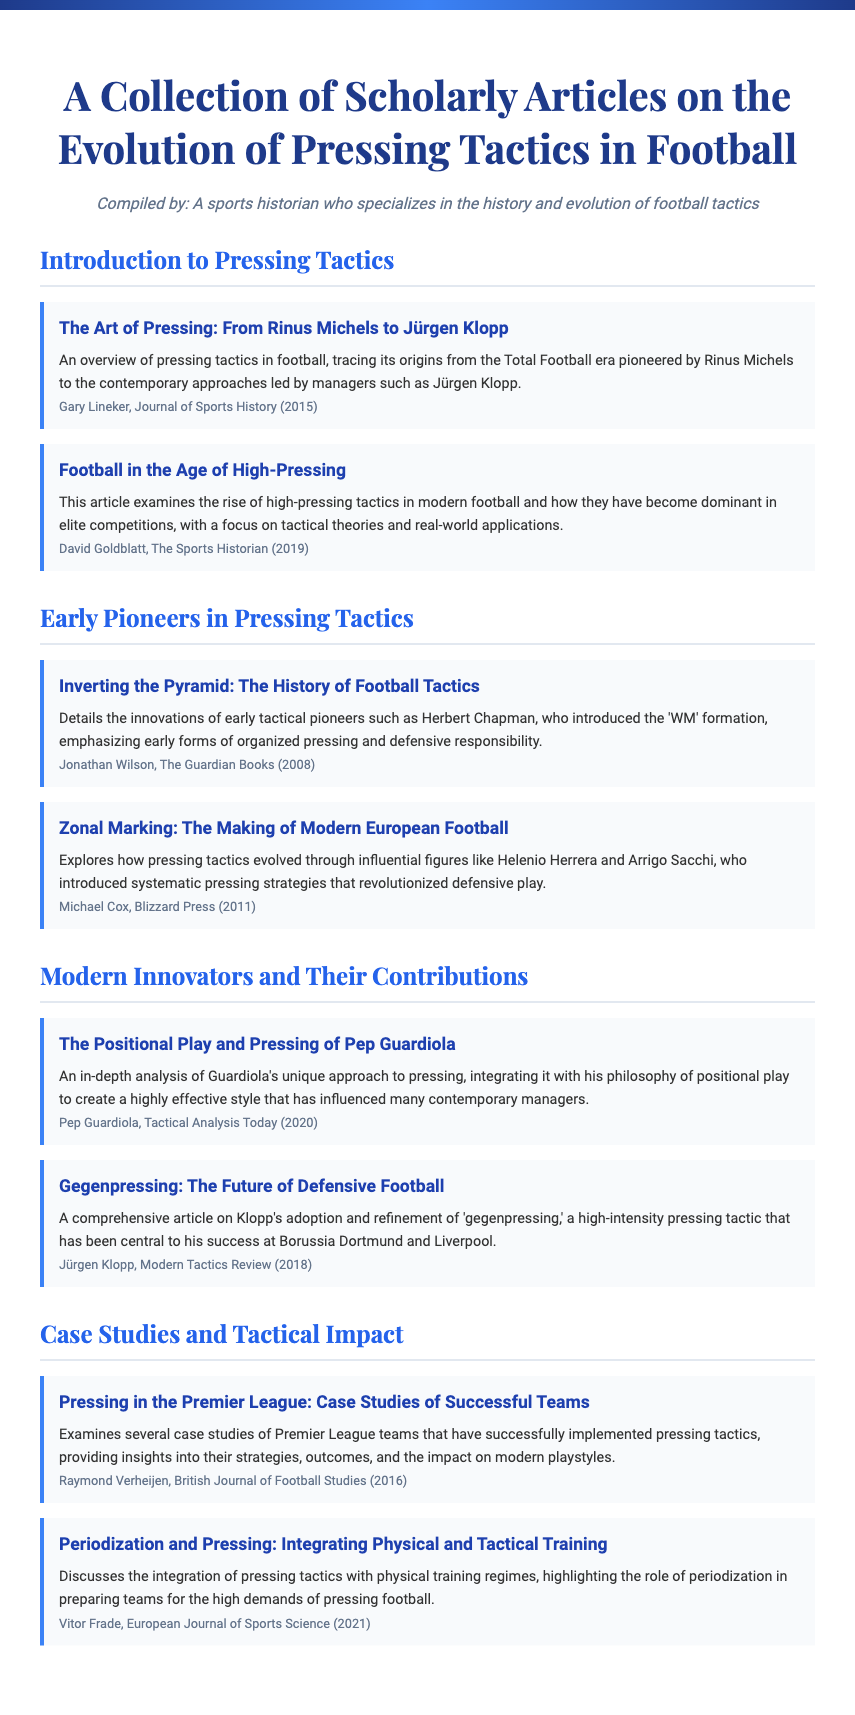what is the title of the first article mentioned? The first article listed under "Introduction to Pressing Tactics" is titled "The Art of Pressing: From Rinus Michels to Jürgen Klopp."
Answer: The Art of Pressing: From Rinus Michels to Jürgen Klopp who wrote the article "Inverting the Pyramid: The History of Football Tactics"? The article "Inverting the Pyramid: The History of Football Tactics" was written by Jonathan Wilson.
Answer: Jonathan Wilson what year was the article "Football in the Age of High-Pressing" published? The article "Football in the Age of High-Pressing" was published in 2019.
Answer: 2019 which tactical approach did Jürgen Klopp refine? Jürgen Klopp refined the tactic known as 'gegenpressing.'
Answer: gegenpressing what is a focus of the article by Raymond Verheijen? The article by Raymond Verheijen focuses on case studies of Premier League teams that successfully implemented pressing tactics.
Answer: case studies of Premier League teams who is identified as an early pioneer in pressing tactics? An early pioneer in pressing tactics identified in the document is Herbert Chapman.
Answer: Herbert Chapman what does Vitor Frade discuss in his article? Vitor Frade discusses the integration of pressing tactics with physical training regimes.
Answer: integration of pressing tactics with physical training regimes name one modern innovator in pressing tactics mentioned in the document. One modern innovator in pressing tactics mentioned is Pep Guardiola.
Answer: Pep Guardiola 